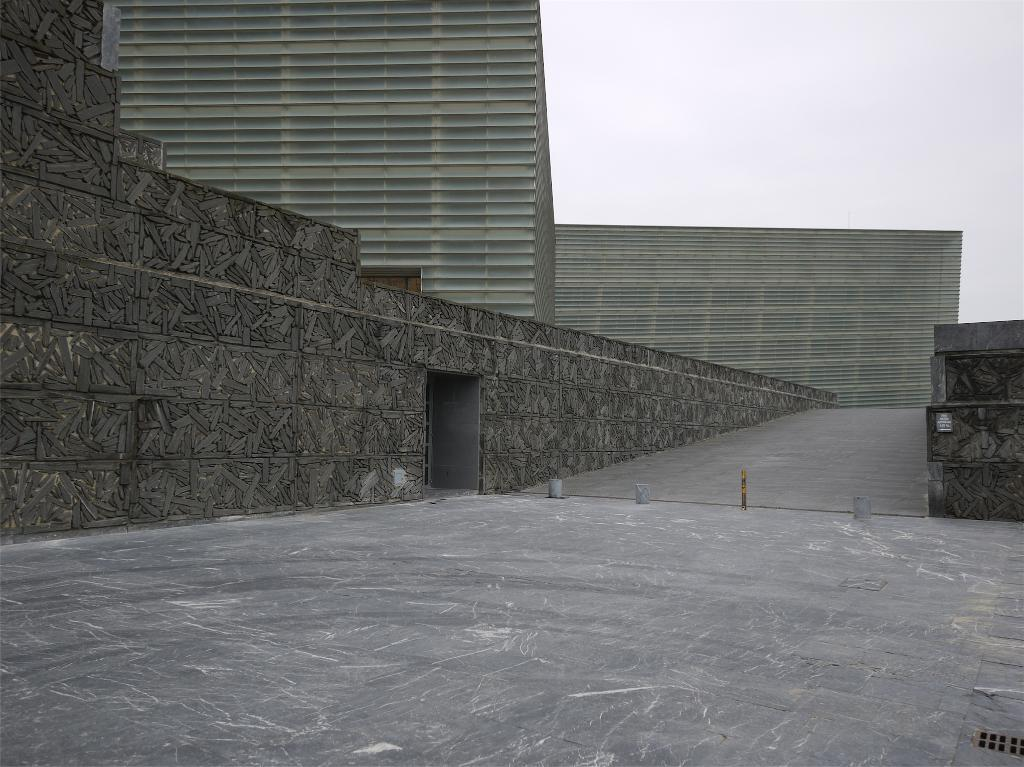What is the main feature of the image? There is a road in the image. What is located next to the road? There is a wall next to the road. What is situated next to the wall? There is a building next to the wall. What can be seen in the background of the image? The sky is visible in the background of the image. Can you tell me how many people are paying attention to the son in the image? There is no person or son present in the image, so it is not possible to answer that question. 